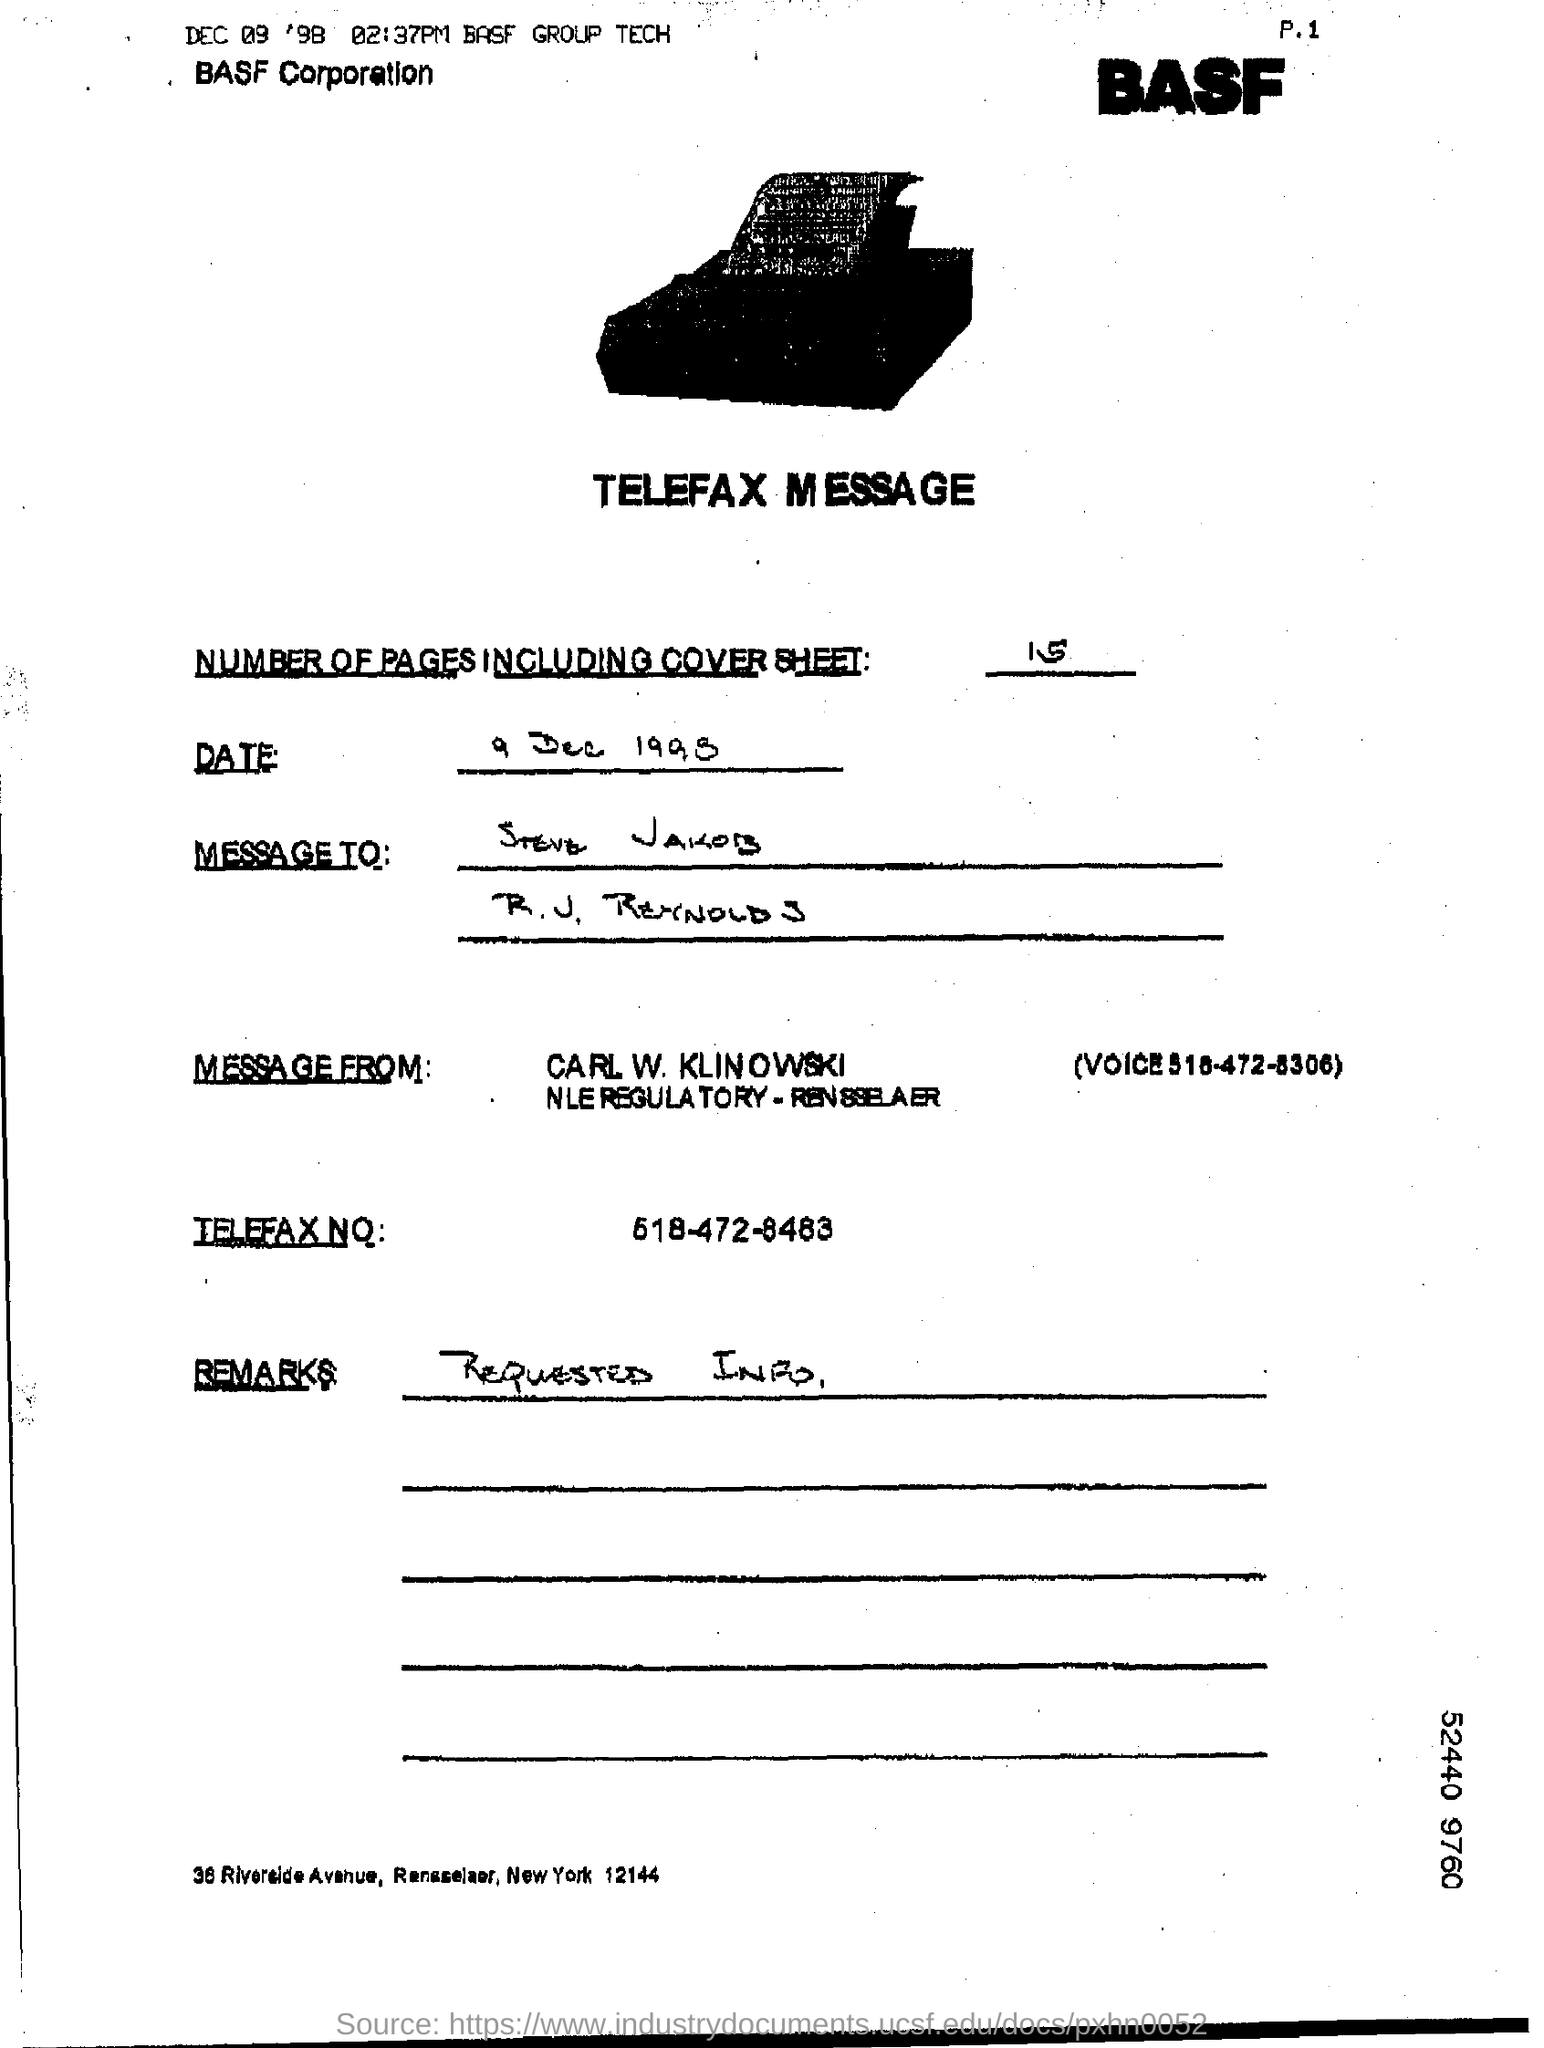What are the Number of pages including Cover sheet?
Offer a very short reply. 15. Who is the message from?
Ensure brevity in your answer.  Carl. W. Klinowski. What is the Telefax No.?
Provide a short and direct response. 518-472-8483. What are the Remarks?
Your answer should be very brief. Requested Info. 